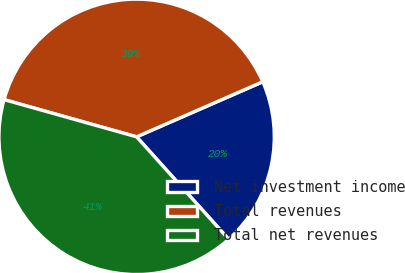<chart> <loc_0><loc_0><loc_500><loc_500><pie_chart><fcel>Net investment income<fcel>Total revenues<fcel>Total net revenues<nl><fcel>19.9%<fcel>39.09%<fcel>41.01%<nl></chart> 